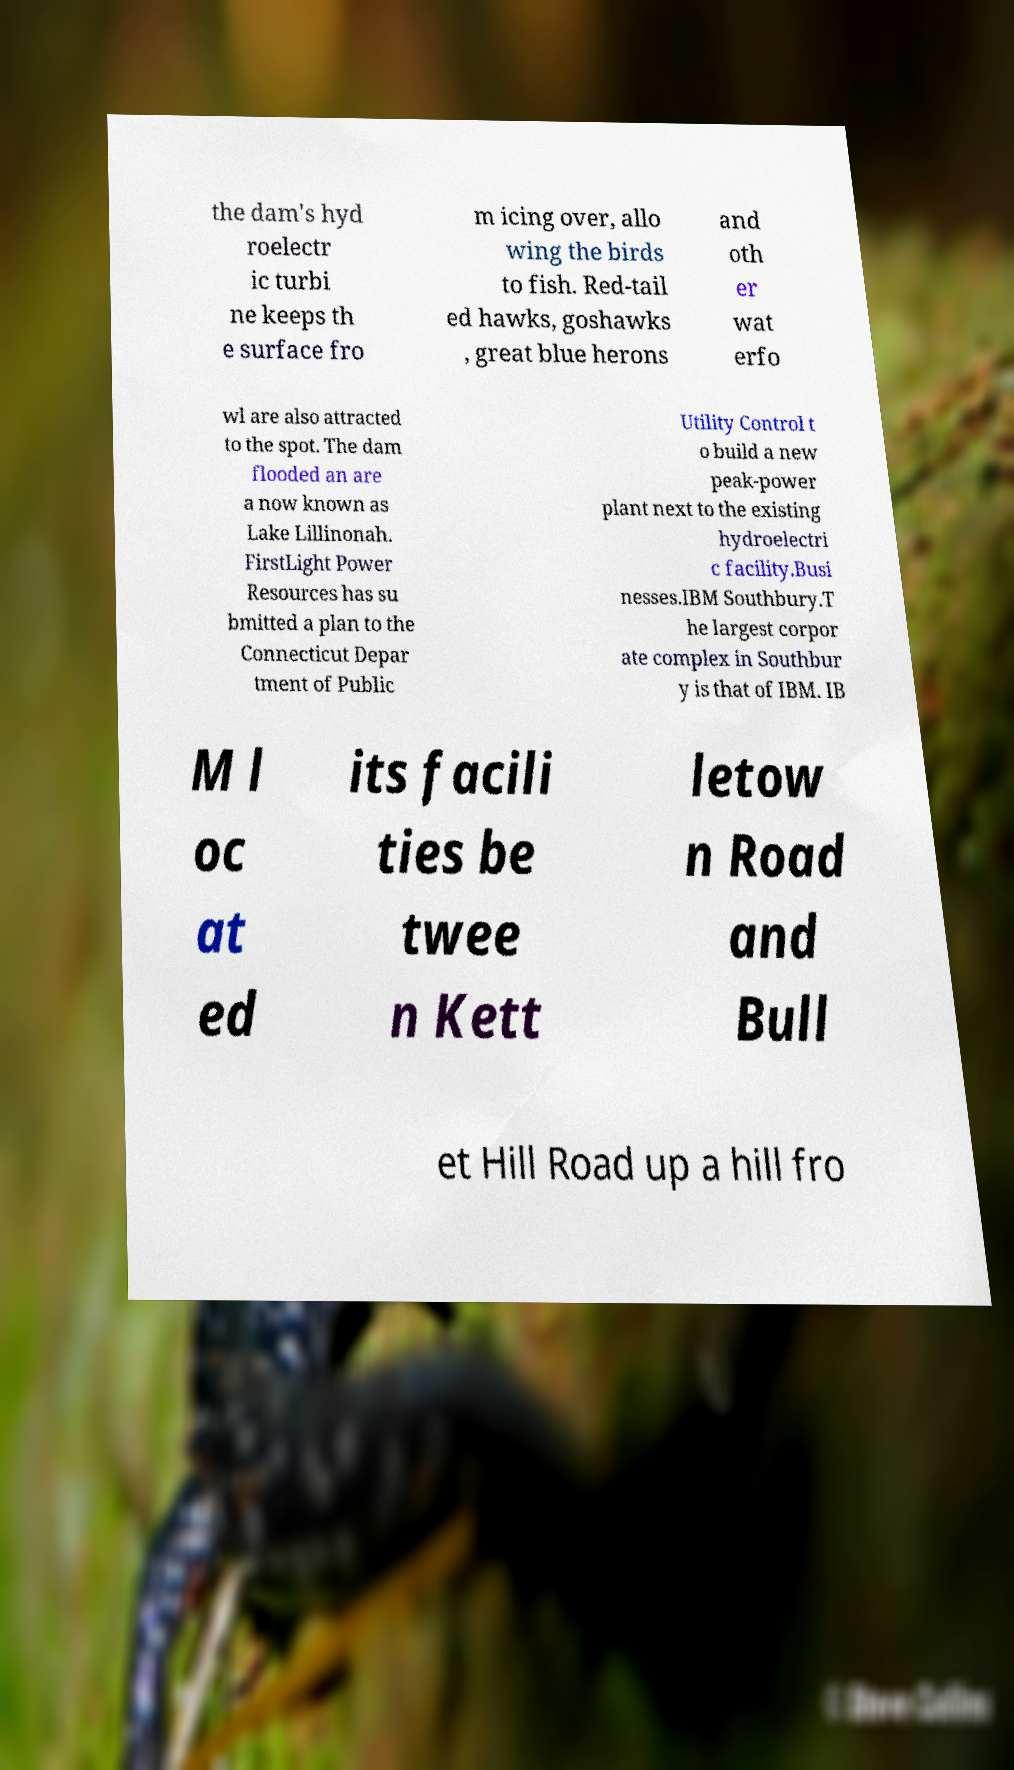Could you assist in decoding the text presented in this image and type it out clearly? the dam's hyd roelectr ic turbi ne keeps th e surface fro m icing over, allo wing the birds to fish. Red-tail ed hawks, goshawks , great blue herons and oth er wat erfo wl are also attracted to the spot. The dam flooded an are a now known as Lake Lillinonah. FirstLight Power Resources has su bmitted a plan to the Connecticut Depar tment of Public Utility Control t o build a new peak-power plant next to the existing hydroelectri c facility.Busi nesses.IBM Southbury.T he largest corpor ate complex in Southbur y is that of IBM. IB M l oc at ed its facili ties be twee n Kett letow n Road and Bull et Hill Road up a hill fro 